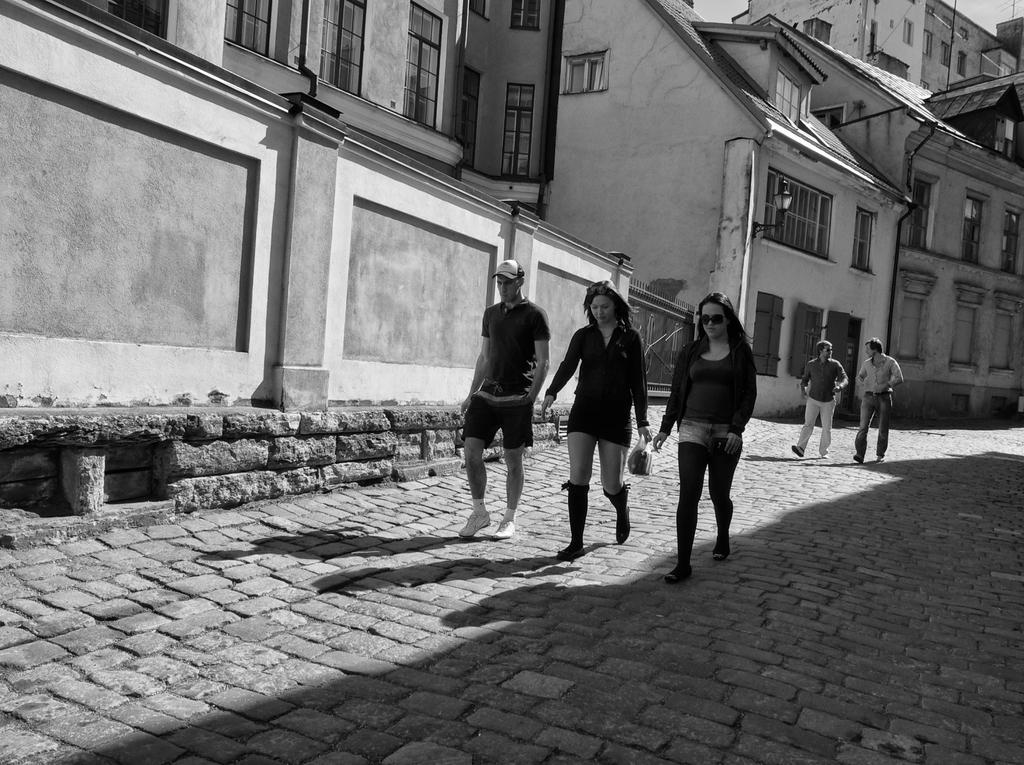In one or two sentences, can you explain what this image depicts? In the image we can see there are people walking, they are wearing clothes and shoes. Here we can see the footpath, buildings and the windows of the buildings. 